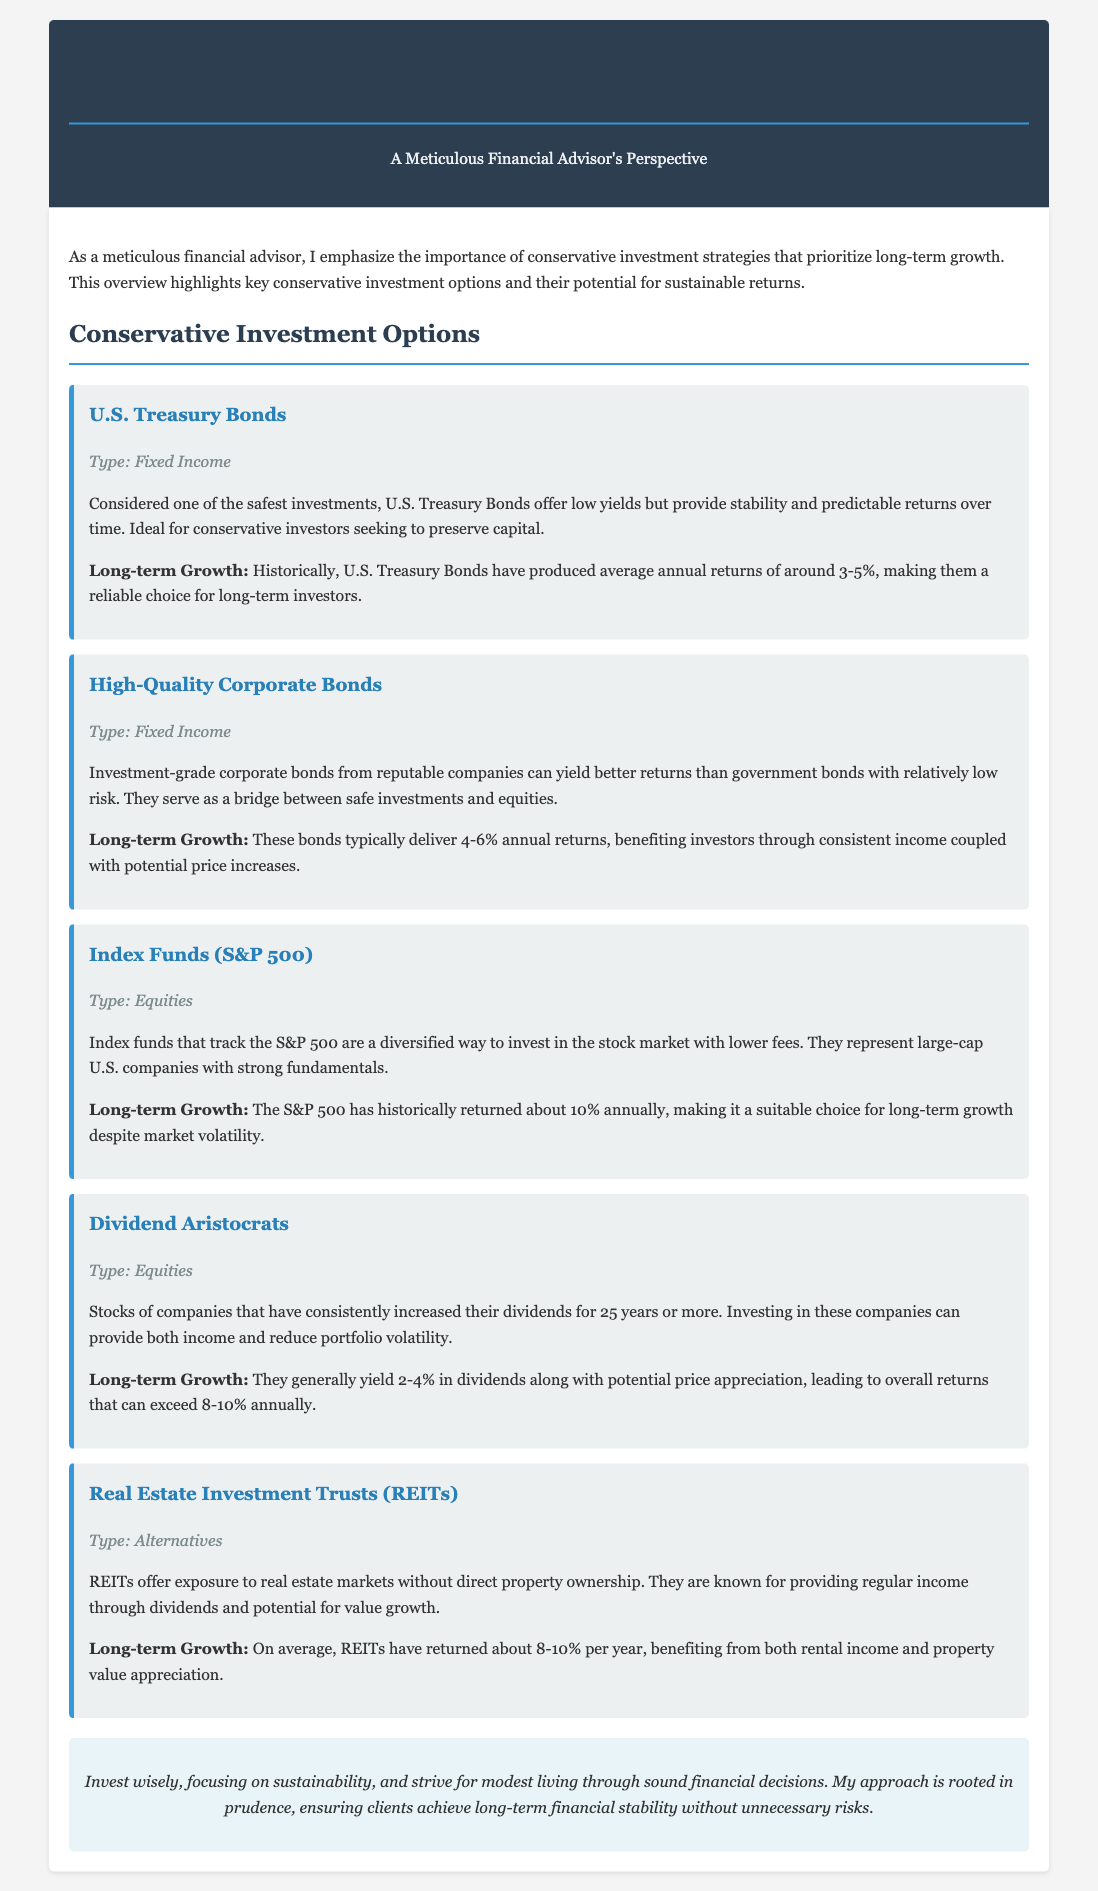What is one of the safest investments? The document states that U.S. Treasury Bonds are considered one of the safest investments.
Answer: U.S. Treasury Bonds What type of investment are Dividend Aristocrats classified as? The Investment Portfolio Overview categorizes Dividend Aristocrats under equities.
Answer: Equities What is the average annual return of U.S. Treasury Bonds? The document mentions that historically, U.S. Treasury Bonds have produced average annual returns of around 3-5%.
Answer: 3-5% What is the long-term growth potential of Real Estate Investment Trusts (REITs)? The document states that on average, REITs have returned about 8-10% per year.
Answer: 8-10% What type of bond provides income and potential price increases? The overview describes high-quality corporate bonds as providing income and potential price increases.
Answer: High-Quality Corporate Bonds What investment option offers exposure to real estate markets? The document identifies Real Estate Investment Trusts (REITs) as offering exposure to real estate markets.
Answer: Real Estate Investment Trusts (REITs) What is the annual return percentage range for Index Funds that track the S&P 500? The document states that the S&P 500 has historically returned about 10% annually.
Answer: 10% What investment option yields dividends between 2-4%? The overview mentions that Dividend Aristocrats generally yield 2-4% in dividends.
Answer: Dividend Aristocrats 